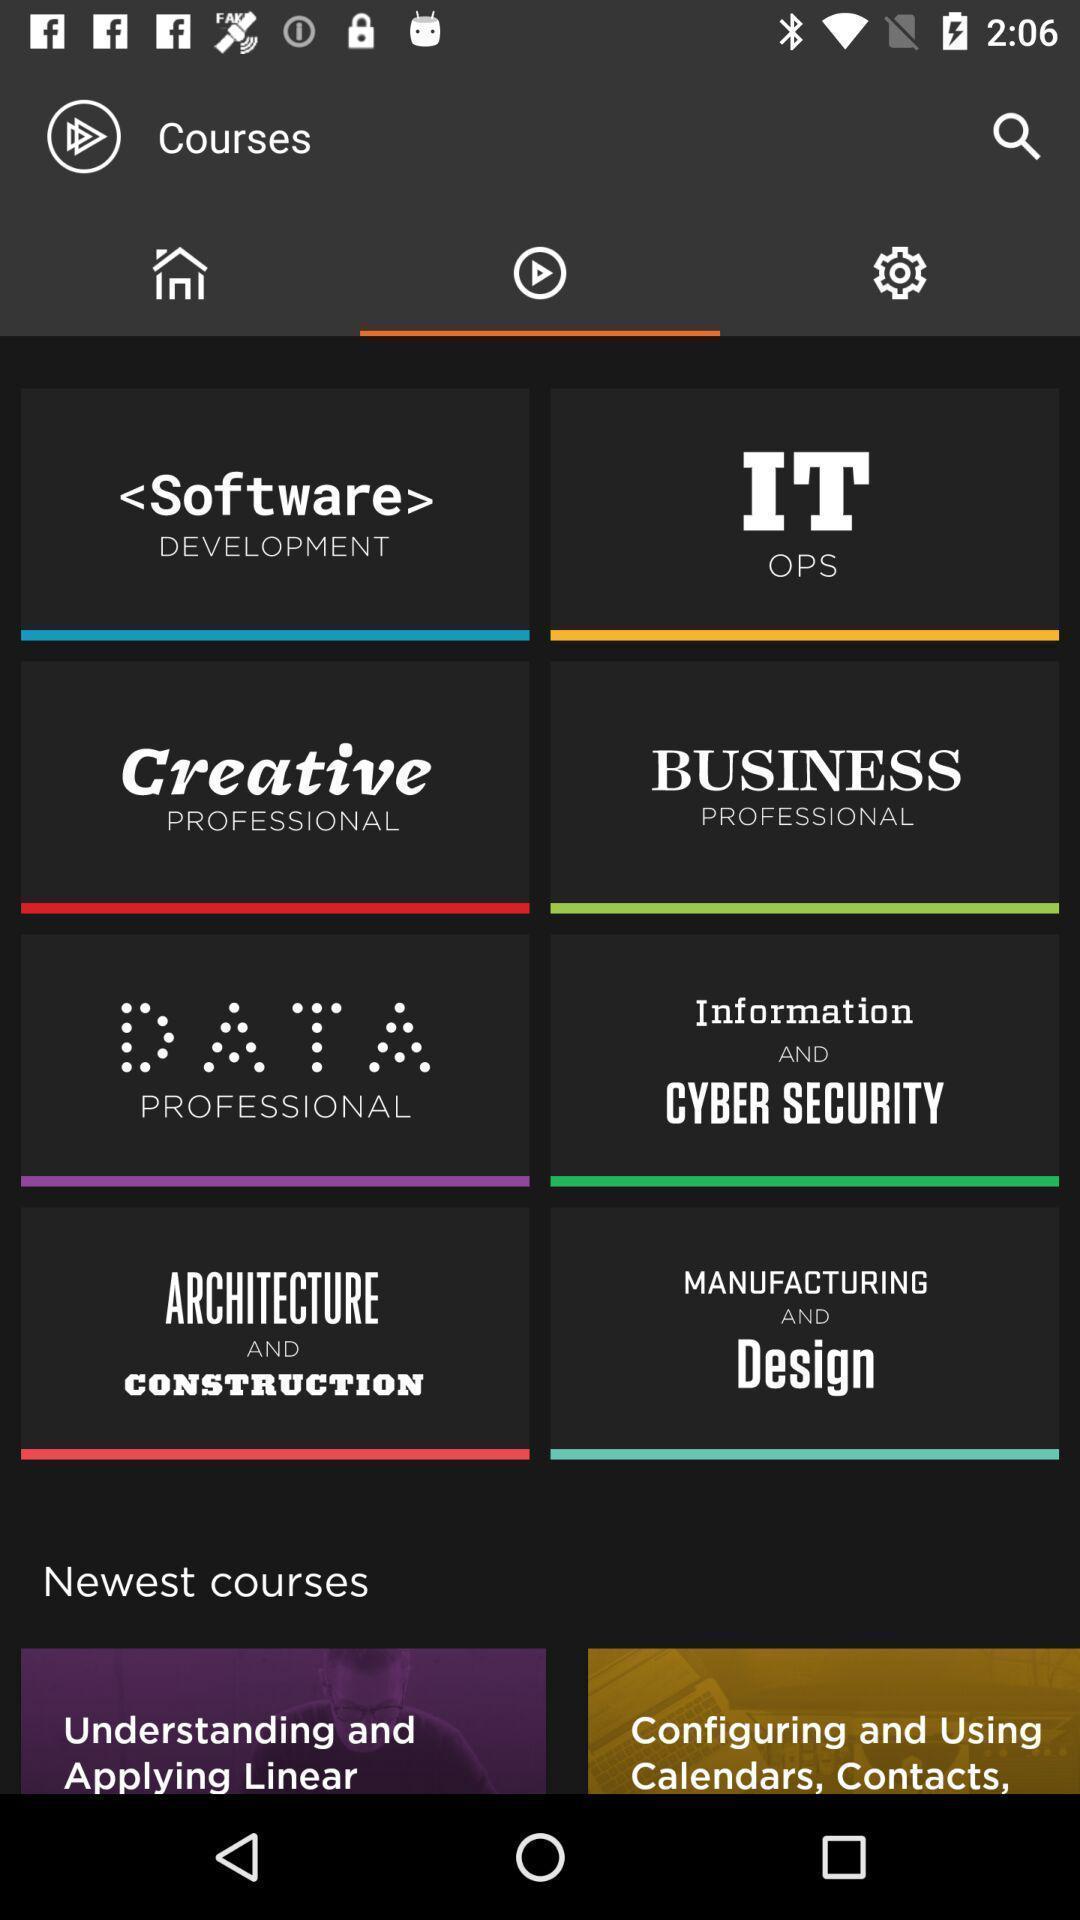What details can you identify in this image? Screen page of a learning application. 